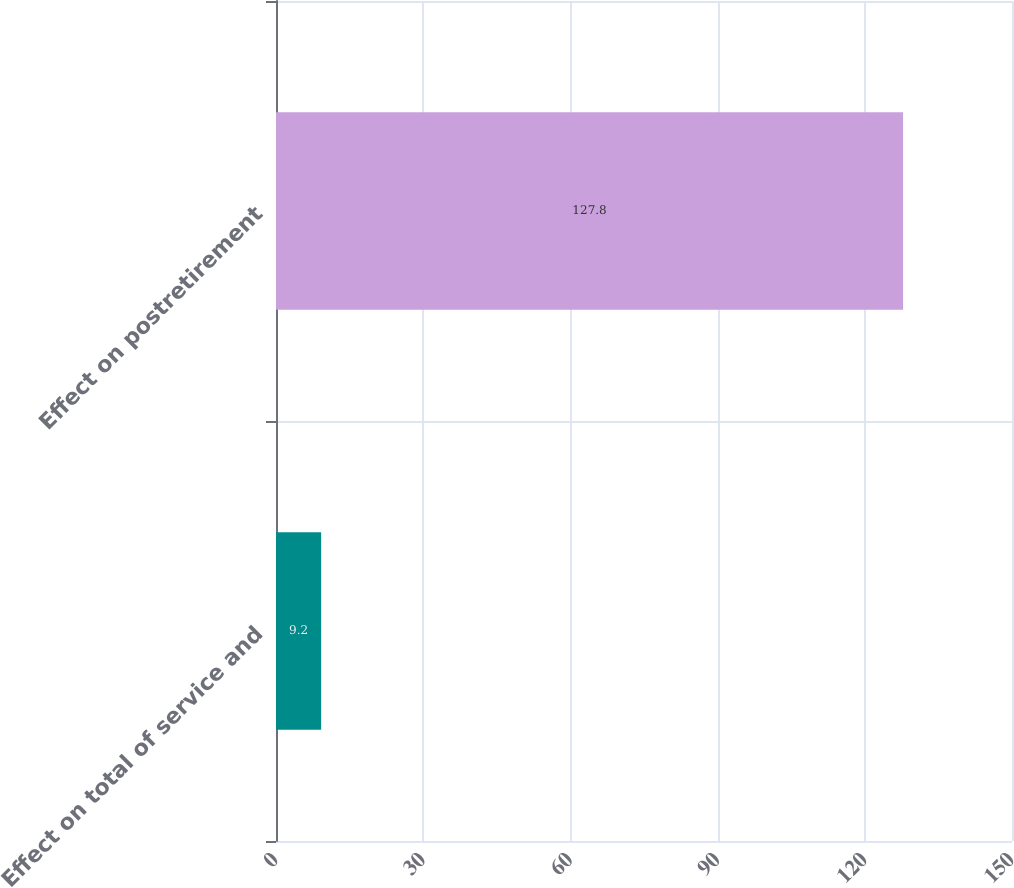<chart> <loc_0><loc_0><loc_500><loc_500><bar_chart><fcel>Effect on total of service and<fcel>Effect on postretirement<nl><fcel>9.2<fcel>127.8<nl></chart> 